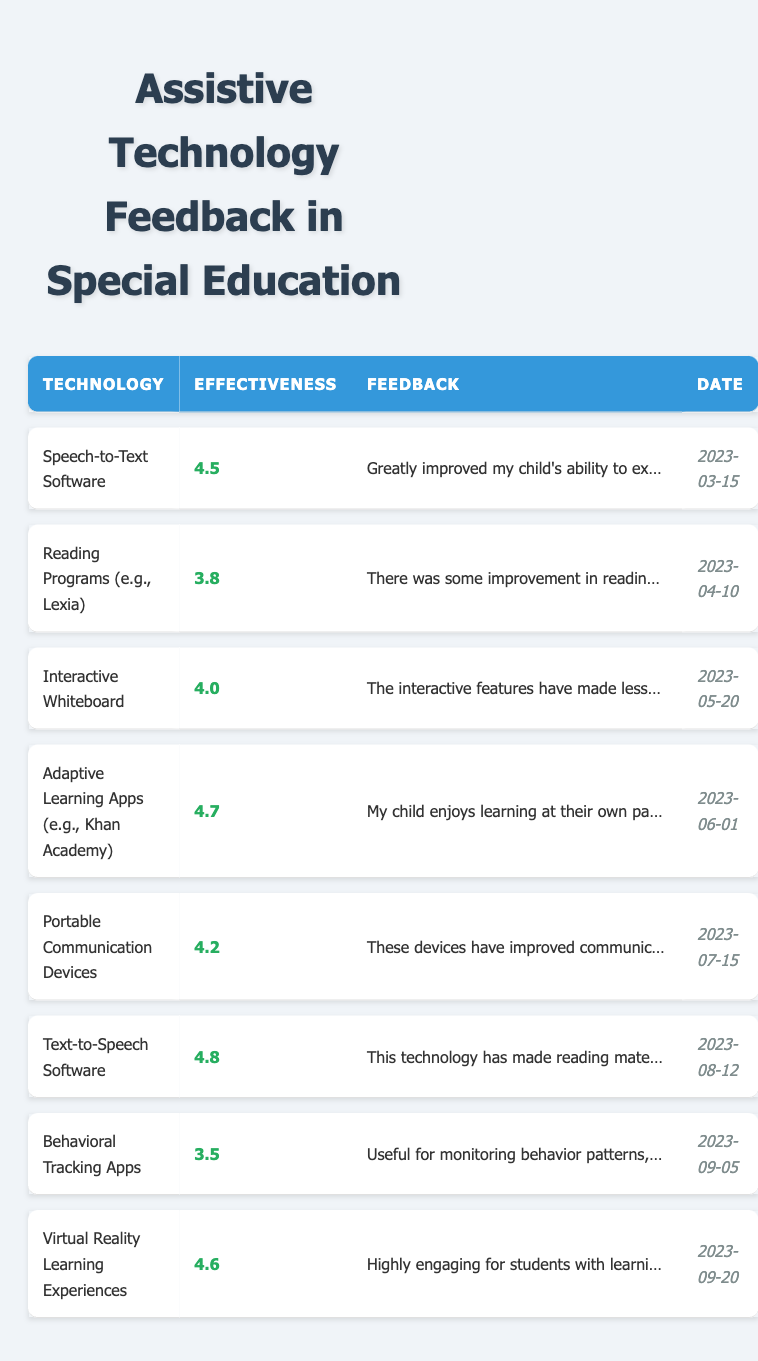What is the highest effectiveness rating among the assistive technologies listed? The highest effectiveness rating can be found by scanning through the Effectiveness column in the table. The maximum value is 4.8, associated with Text-to-Speech Software.
Answer: 4.8 Who provided feedback on the Interactive Whiteboard technology? To answer this, look for the row that lists Interactive Whiteboard. The feedback was provided by James Thompson, as listed in that row.
Answer: James Thompson What is the average effectiveness rating of the assistive technologies? To find the average, sum all the effectiveness ratings: (4.5 + 3.8 + 4.0 + 4.7 + 4.2 + 4.8 + 3.5 + 4.6) = 34.1. There are 8 ratings, so divide by 8: 34.1 / 8 = 4.2625, which we can round to 4.26.
Answer: 4.26 Is the feedback for Adaptive Learning Apps positive? The feedback from Patricia Green states her child enjoys learning at their own pace, which is a positive comment regarding effectiveness.
Answer: Yes Which technology had the lowest effectiveness rating, and who provided that feedback? The row with the lowest effectiveness rating is Behavioral Tracking Apps, which has a rating of 3.5 provided by Jessica Hernandez.
Answer: Behavioral Tracking Apps, Jessica Hernandez How many technologies received an effectiveness rating of 4.0 or higher? Review the ratings in the table and count those that are 4.0 or higher: 4.5, 4.0, 4.7, 4.2, 4.8, 4.6. This totals to 6 technologies.
Answer: 6 Did any parents mention improvements in their child’s engagement? Check through the feedbacks to see if any mention engagement. Emily Johnson stated a significant increase in engagement with Speech-to-Text Software.
Answer: Yes What was the date when the feedback for Portable Communication Devices was given? Locate the row for Portable Communication Devices in the table, where the date is provided. The date given is 2023-07-15.
Answer: 2023-07-15 Which two technologies received feedback mentioning issues with engagement? Look for feedbacks that mention engagement concerns. Reading Programs mentioned could be more engaging, and Behavioral Tracking Apps described an interface that is not intuitive.
Answer: Reading Programs, Behavioral Tracking Apps If we consider only technologies with an effectiveness rating below 4.0, how many such technologies are there? Check the ratings: both Reading Programs (3.8) and Behavioral Tracking Apps (3.5) have ratings below 4.0, leading to a total of 2 technologies.
Answer: 2 